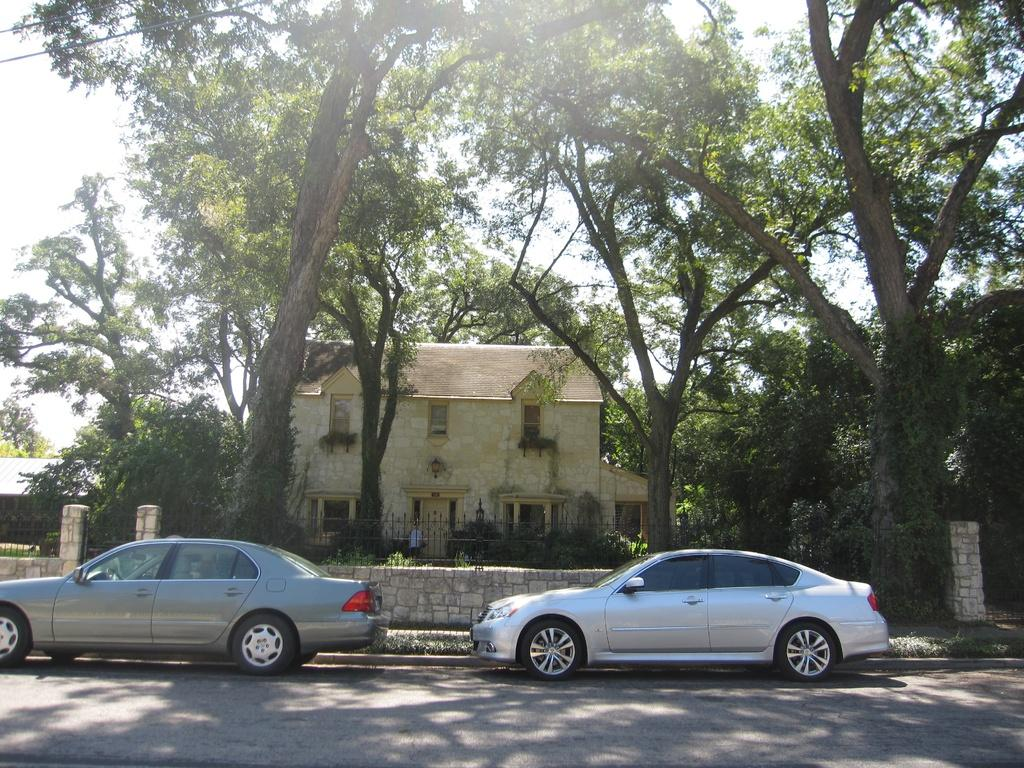What type of vehicles are parked on the side of the road in the image? There are two silver color cars parked on the side of the road in the image. What structures can be seen in the image? There is a stone wall, a fence, and a house in the image. What type of vegetation is visible in the background of the image? There are trees in the background of the image. What part of the natural environment is visible in the image? The sky is visible in the background of the image. What type of authority figure can be seen in the image? There is no authority figure present in the image. What musical instrument is being played in the image? There is no musical instrument being played in the image. 